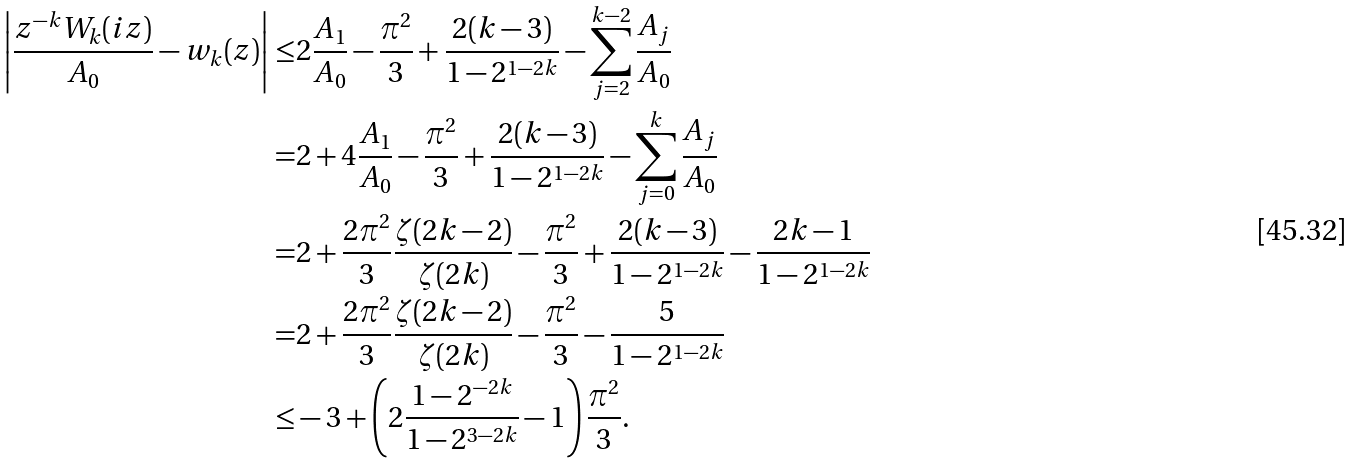<formula> <loc_0><loc_0><loc_500><loc_500>\left | \frac { z ^ { - k } W _ { k } ( i z ) } { A _ { 0 } } - w _ { k } ( z ) \right | \leq & 2 \frac { A _ { 1 } } { A _ { 0 } } - \frac { \pi ^ { 2 } } { 3 } + \frac { 2 ( k - 3 ) } { 1 - 2 ^ { 1 - 2 k } } - \sum _ { j = 2 } ^ { k - 2 } \frac { A _ { j } } { A _ { 0 } } \\ = & 2 + 4 \frac { A _ { 1 } } { A _ { 0 } } - \frac { \pi ^ { 2 } } { 3 } + \frac { 2 ( k - 3 ) } { 1 - 2 ^ { 1 - 2 k } } - \sum _ { j = 0 } ^ { k } \frac { A _ { j } } { A _ { 0 } } \\ = & 2 + \frac { 2 \pi ^ { 2 } } { 3 } \frac { \zeta ( 2 k - 2 ) } { \zeta ( 2 k ) } - \frac { \pi ^ { 2 } } { 3 } + \frac { 2 ( k - 3 ) } { 1 - 2 ^ { 1 - 2 k } } - \frac { 2 k - 1 } { 1 - 2 ^ { 1 - 2 k } } \\ = & 2 + \frac { 2 \pi ^ { 2 } } { 3 } \frac { \zeta ( 2 k - 2 ) } { \zeta ( 2 k ) } - \frac { \pi ^ { 2 } } { 3 } - \frac { 5 } { 1 - 2 ^ { 1 - 2 k } } \\ \leq & - 3 + \left ( 2 \frac { 1 - 2 ^ { - 2 k } } { 1 - 2 ^ { 3 - 2 k } } - 1 \right ) \frac { \pi ^ { 2 } } { 3 } .</formula> 